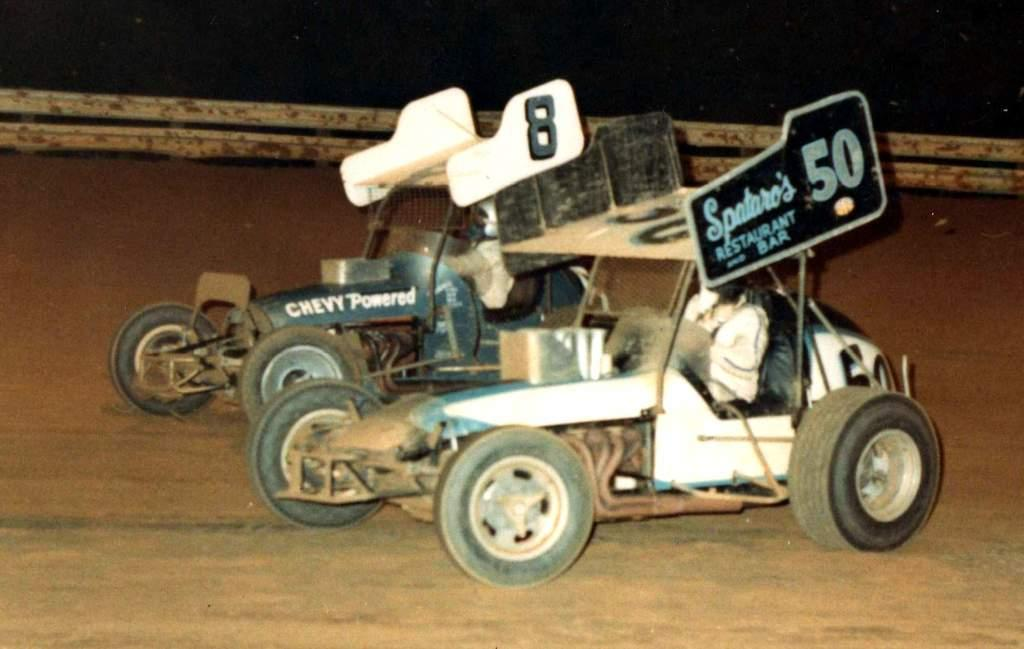What can be seen in the foreground of the image? There are two vehicles in the foreground of the image. Who is on the vehicles? Two persons are sitting on the vehicles. What is at the bottom of the image? There is a road at the bottom of the image. What is visible in the background of the image? There is a fence in the background of the image. What type of argument is taking place between the two persons on the vehicles? There is no indication of an argument in the image; the two persons are simply sitting on the vehicles. How many boys are visible in the image? The provided facts do not mention the gender of the persons on the vehicles, so it cannot be determined if any of them are boys. 